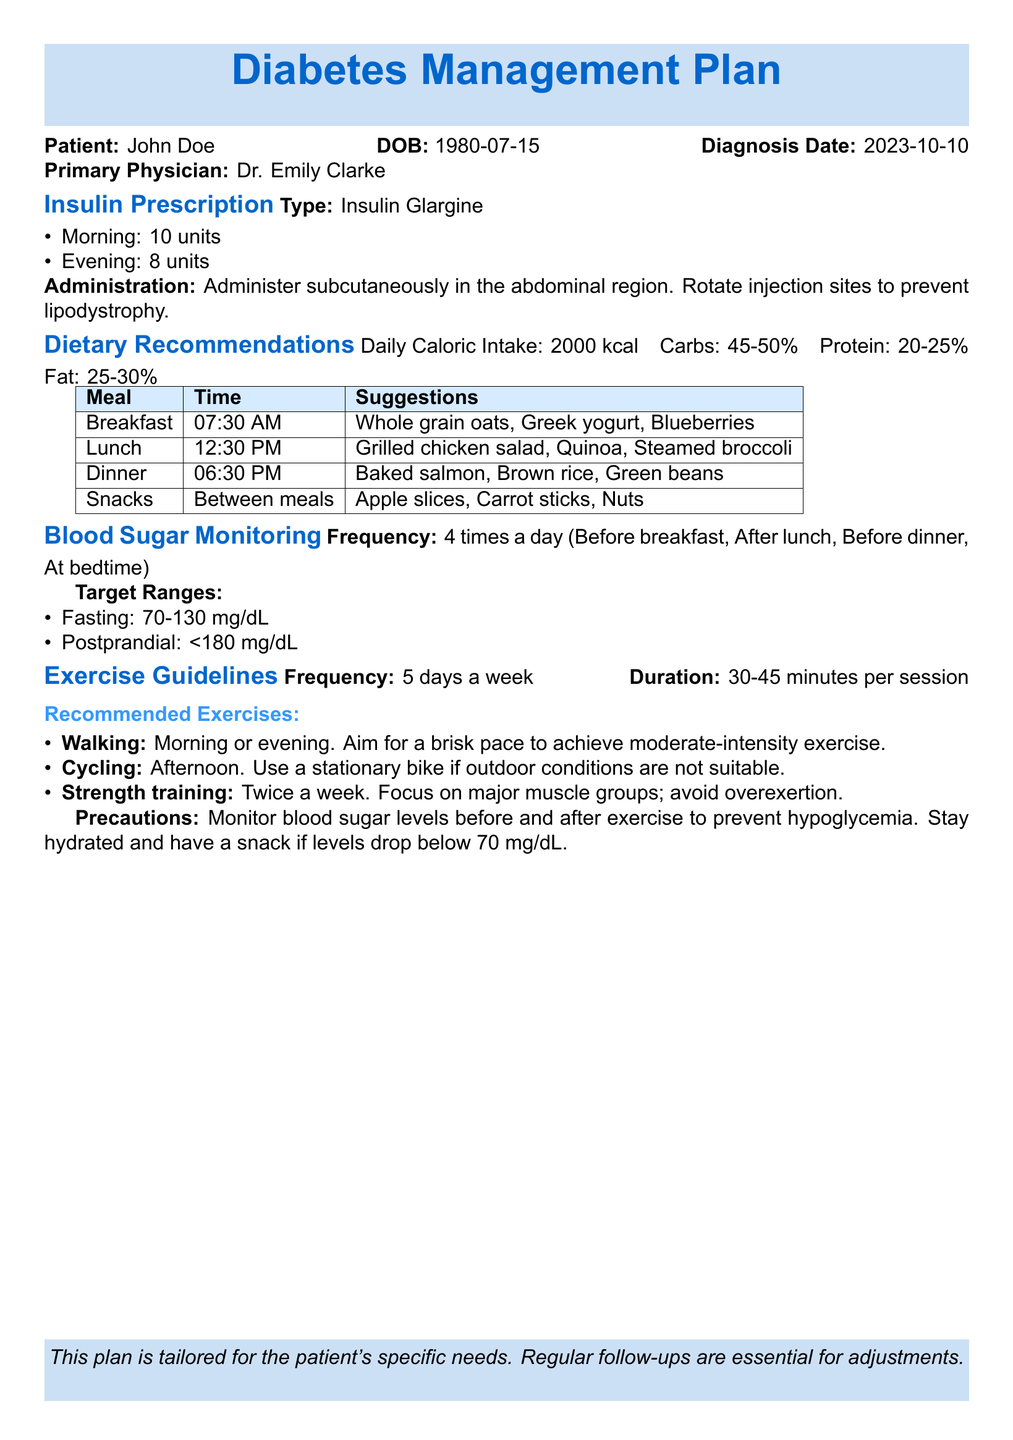What is the patient's name? The document states the patient's name is John Doe.
Answer: John Doe What is the prescribed morning insulin dose? The document specifies the morning insulin dose is 10 units.
Answer: 10 units What is the daily caloric intake recommendation? The document recommends a daily caloric intake of 2000 kcal.
Answer: 2000 kcal How many times a day should blood sugar be monitored? The document indicates blood sugar should be monitored 4 times a day.
Answer: 4 times a day What is the fasting blood sugar target range? The document provides a target range for fasting blood sugar of 70-130 mg/dL.
Answer: 70-130 mg/dL What type of insulin is prescribed? The document states the type of insulin prescribed is Insulin Glargine.
Answer: Insulin Glargine What is the recommended duration for exercise sessions? The document suggests a duration of 30-45 minutes per session for exercise.
Answer: 30-45 minutes How often should strength training occur? The document specifies strength training should occur twice a week.
Answer: Twice a week What meal is suggested at 12:30 PM? The document suggests a Grilled chicken salad, Quinoa, Steamed broccoli for lunch at 12:30 PM.
Answer: Grilled chicken salad, Quinoa, Steamed broccoli 